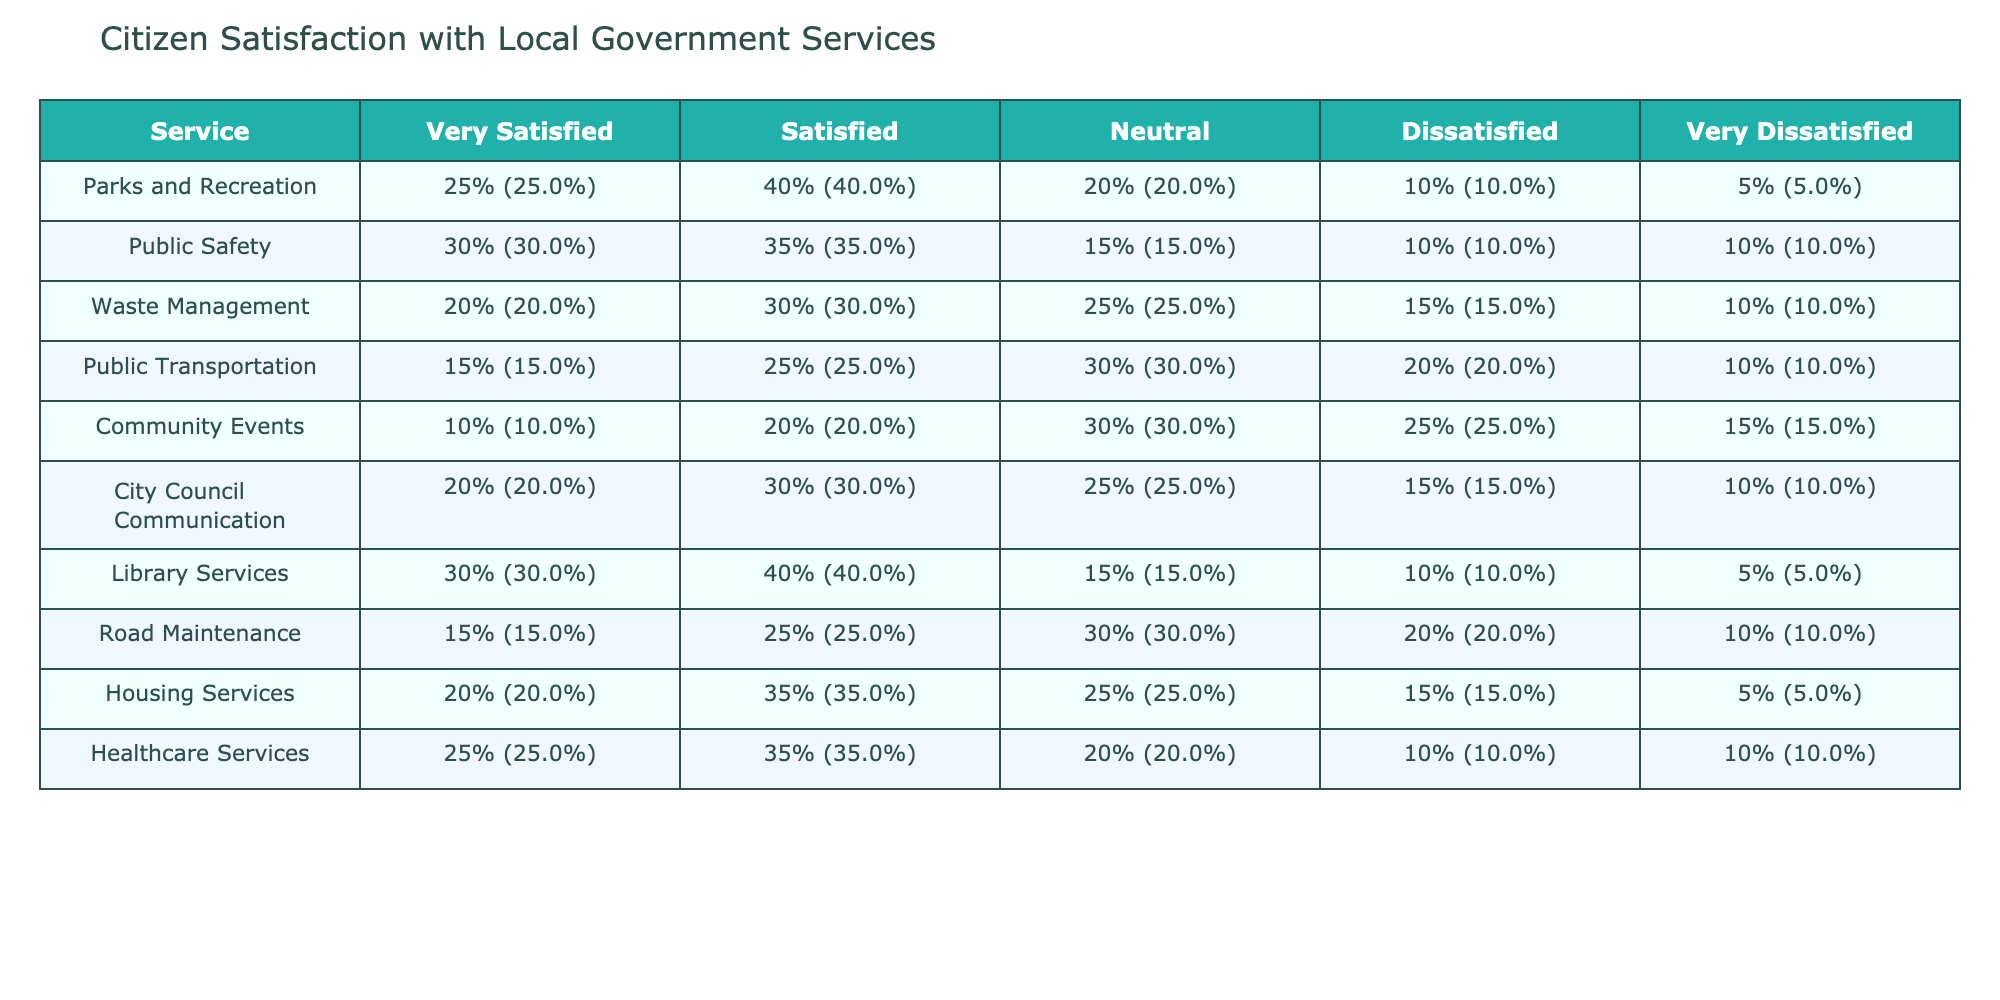What percentage of citizens are very satisfied with Library Services? The table indicates that 30% of citizens are very satisfied with Library Services.
Answer: 30% Which service has the highest percentage of citizens who are dissatisfied? The highest percentage of dissatisfaction is found in Community Events, with 25% of respondents indicating they are dissatisfied.
Answer: 25% What is the overall satisfaction (very satisfied + satisfied) percentage for Public Safety? The satisfied percentages for Public Safety are 30% (very satisfied) + 35% (satisfied) = 65%.
Answer: 65% Are more citizens satisfied with Waste Management than Public Transportation? For Waste Management, 20% (very satisfied) + 30% (satisfied) = 50% satisfied overall, while Public Transportation has 15% (very satisfied) + 25% (satisfied) = 40% overall. Yes, more citizens are satisfied with Waste Management.
Answer: Yes If we compare very satisfied percentages, which service shows the largest gap in dissatisfaction? Calculating the gap between very satisfied and very dissatisfied percentages for each service, Parks and Recreation shows a gap of 20% (25% very satisfied vs. 5% very dissatisfied), which is the largest.
Answer: 20% 